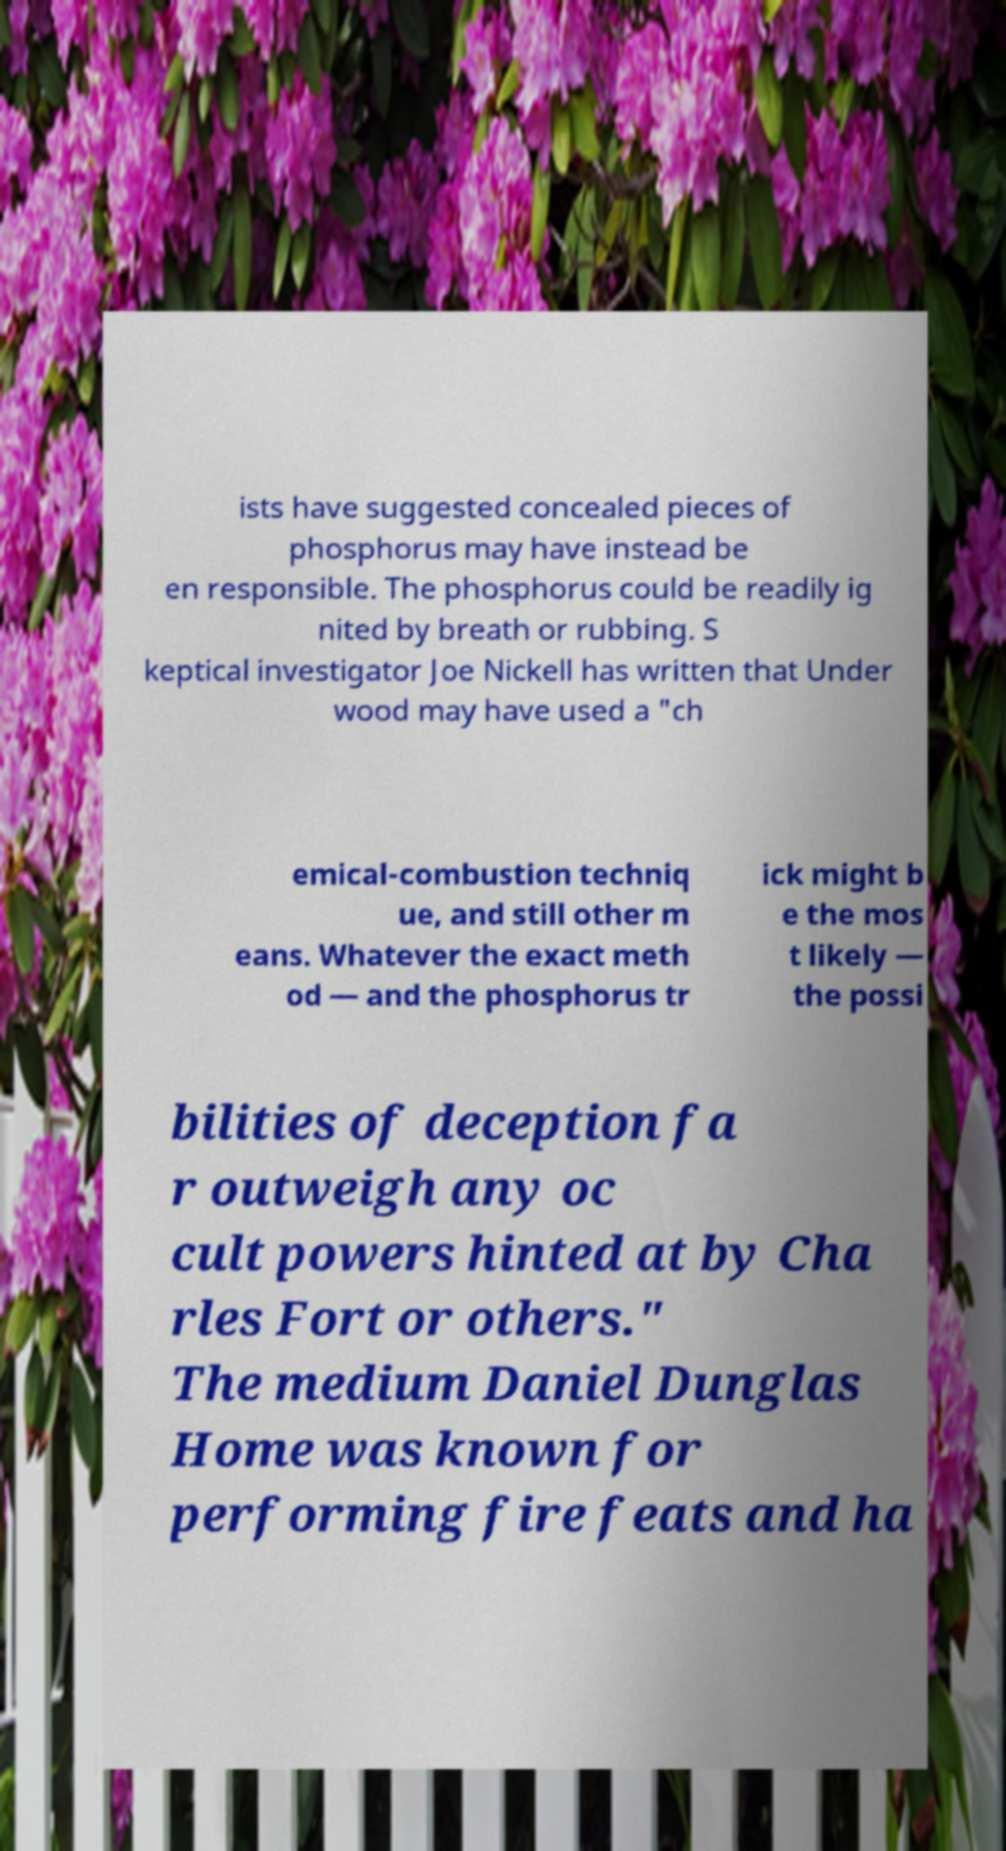For documentation purposes, I need the text within this image transcribed. Could you provide that? ists have suggested concealed pieces of phosphorus may have instead be en responsible. The phosphorus could be readily ig nited by breath or rubbing. S keptical investigator Joe Nickell has written that Under wood may have used a "ch emical-combustion techniq ue, and still other m eans. Whatever the exact meth od — and the phosphorus tr ick might b e the mos t likely — the possi bilities of deception fa r outweigh any oc cult powers hinted at by Cha rles Fort or others." The medium Daniel Dunglas Home was known for performing fire feats and ha 